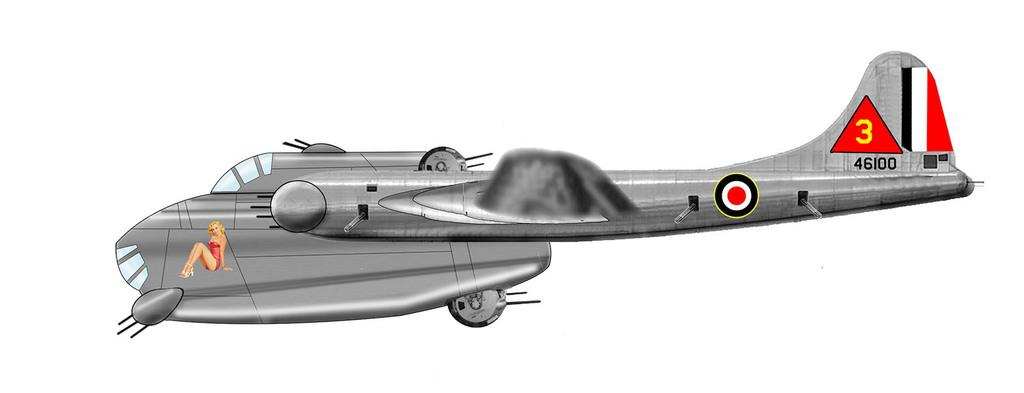<image>
Write a terse but informative summary of the picture. A small grey plane with the number 3 on the  tail. 